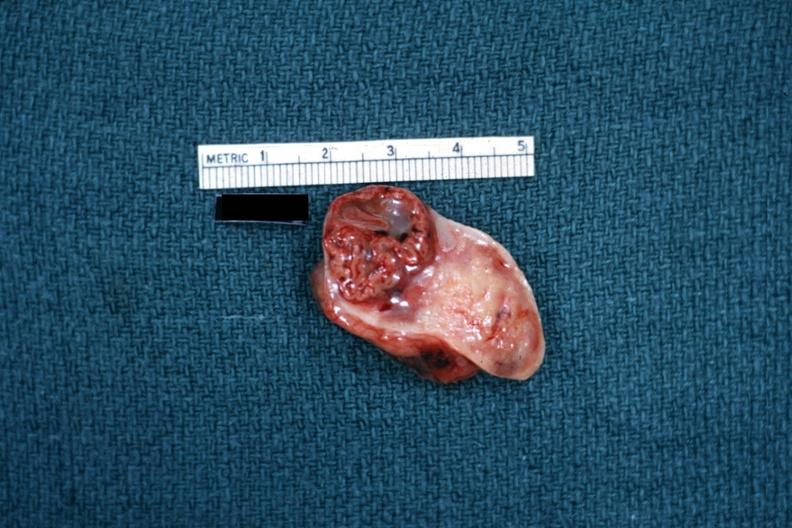does this image show excellent example close-up photo of corpus luteum?
Answer the question using a single word or phrase. Yes 